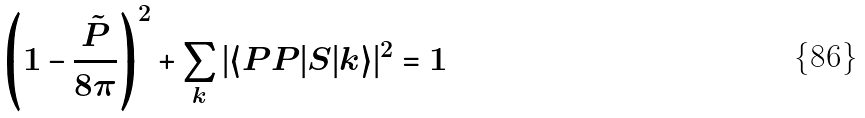<formula> <loc_0><loc_0><loc_500><loc_500>\left ( 1 - \frac { \tilde { P } } { 8 \pi } \right ) ^ { 2 } + \sum _ { k } | \langle P P | S | k \rangle | ^ { 2 } = 1</formula> 